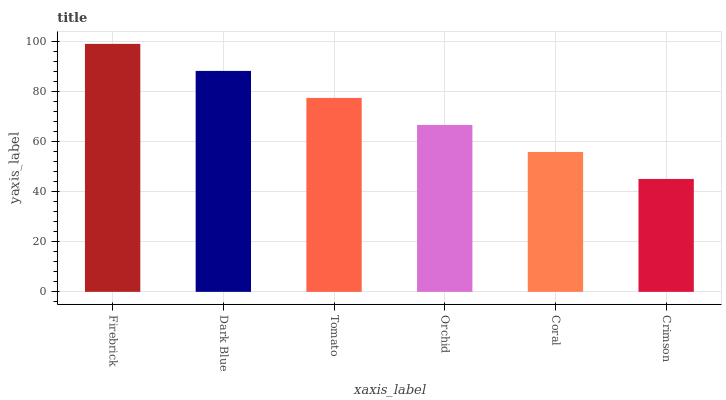Is Crimson the minimum?
Answer yes or no. Yes. Is Firebrick the maximum?
Answer yes or no. Yes. Is Dark Blue the minimum?
Answer yes or no. No. Is Dark Blue the maximum?
Answer yes or no. No. Is Firebrick greater than Dark Blue?
Answer yes or no. Yes. Is Dark Blue less than Firebrick?
Answer yes or no. Yes. Is Dark Blue greater than Firebrick?
Answer yes or no. No. Is Firebrick less than Dark Blue?
Answer yes or no. No. Is Tomato the high median?
Answer yes or no. Yes. Is Orchid the low median?
Answer yes or no. Yes. Is Coral the high median?
Answer yes or no. No. Is Crimson the low median?
Answer yes or no. No. 